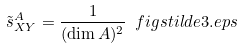<formula> <loc_0><loc_0><loc_500><loc_500>\tilde { s } ^ { A } _ { X Y } = \frac { 1 } { ( \dim A ) ^ { 2 } } \ f i g { s t i l d e 3 . e p s }</formula> 